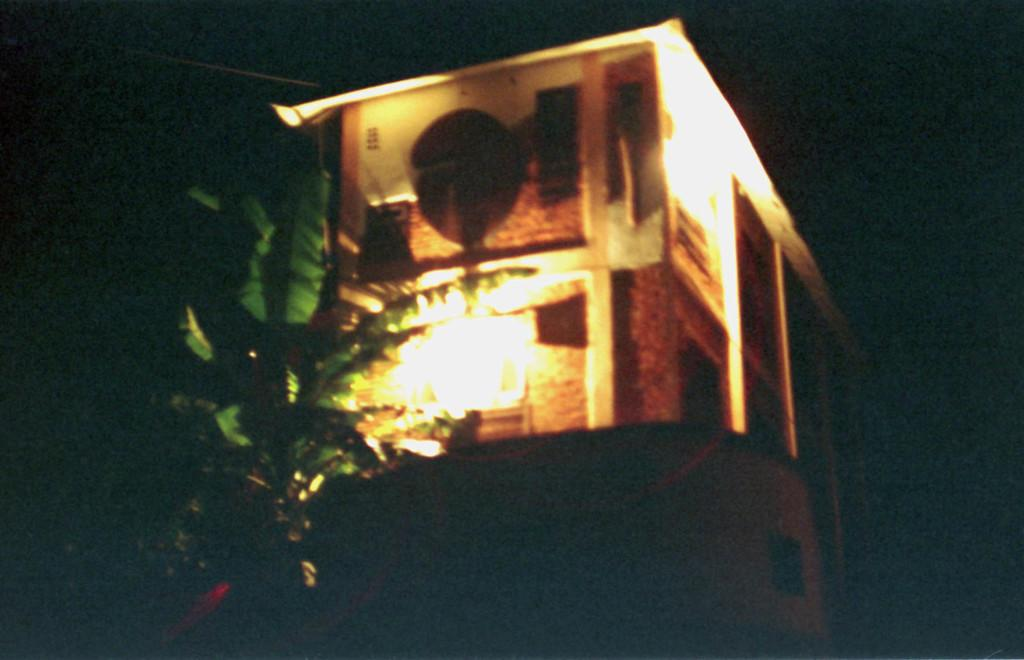What is the main structure in the picture? There is a building in the picture. What natural element is present in the image? There is a tree in the picture. What feature is added to the building in the image? Lights are attached to the building. How would you describe the overall lighting in the image? The backdrop of the image is dark. What type of song is being sung by the ladybug in the image? There is no ladybug present in the image, and therefore no singing can be observed. What is the engine used for in the image? There is no engine present in the image. 